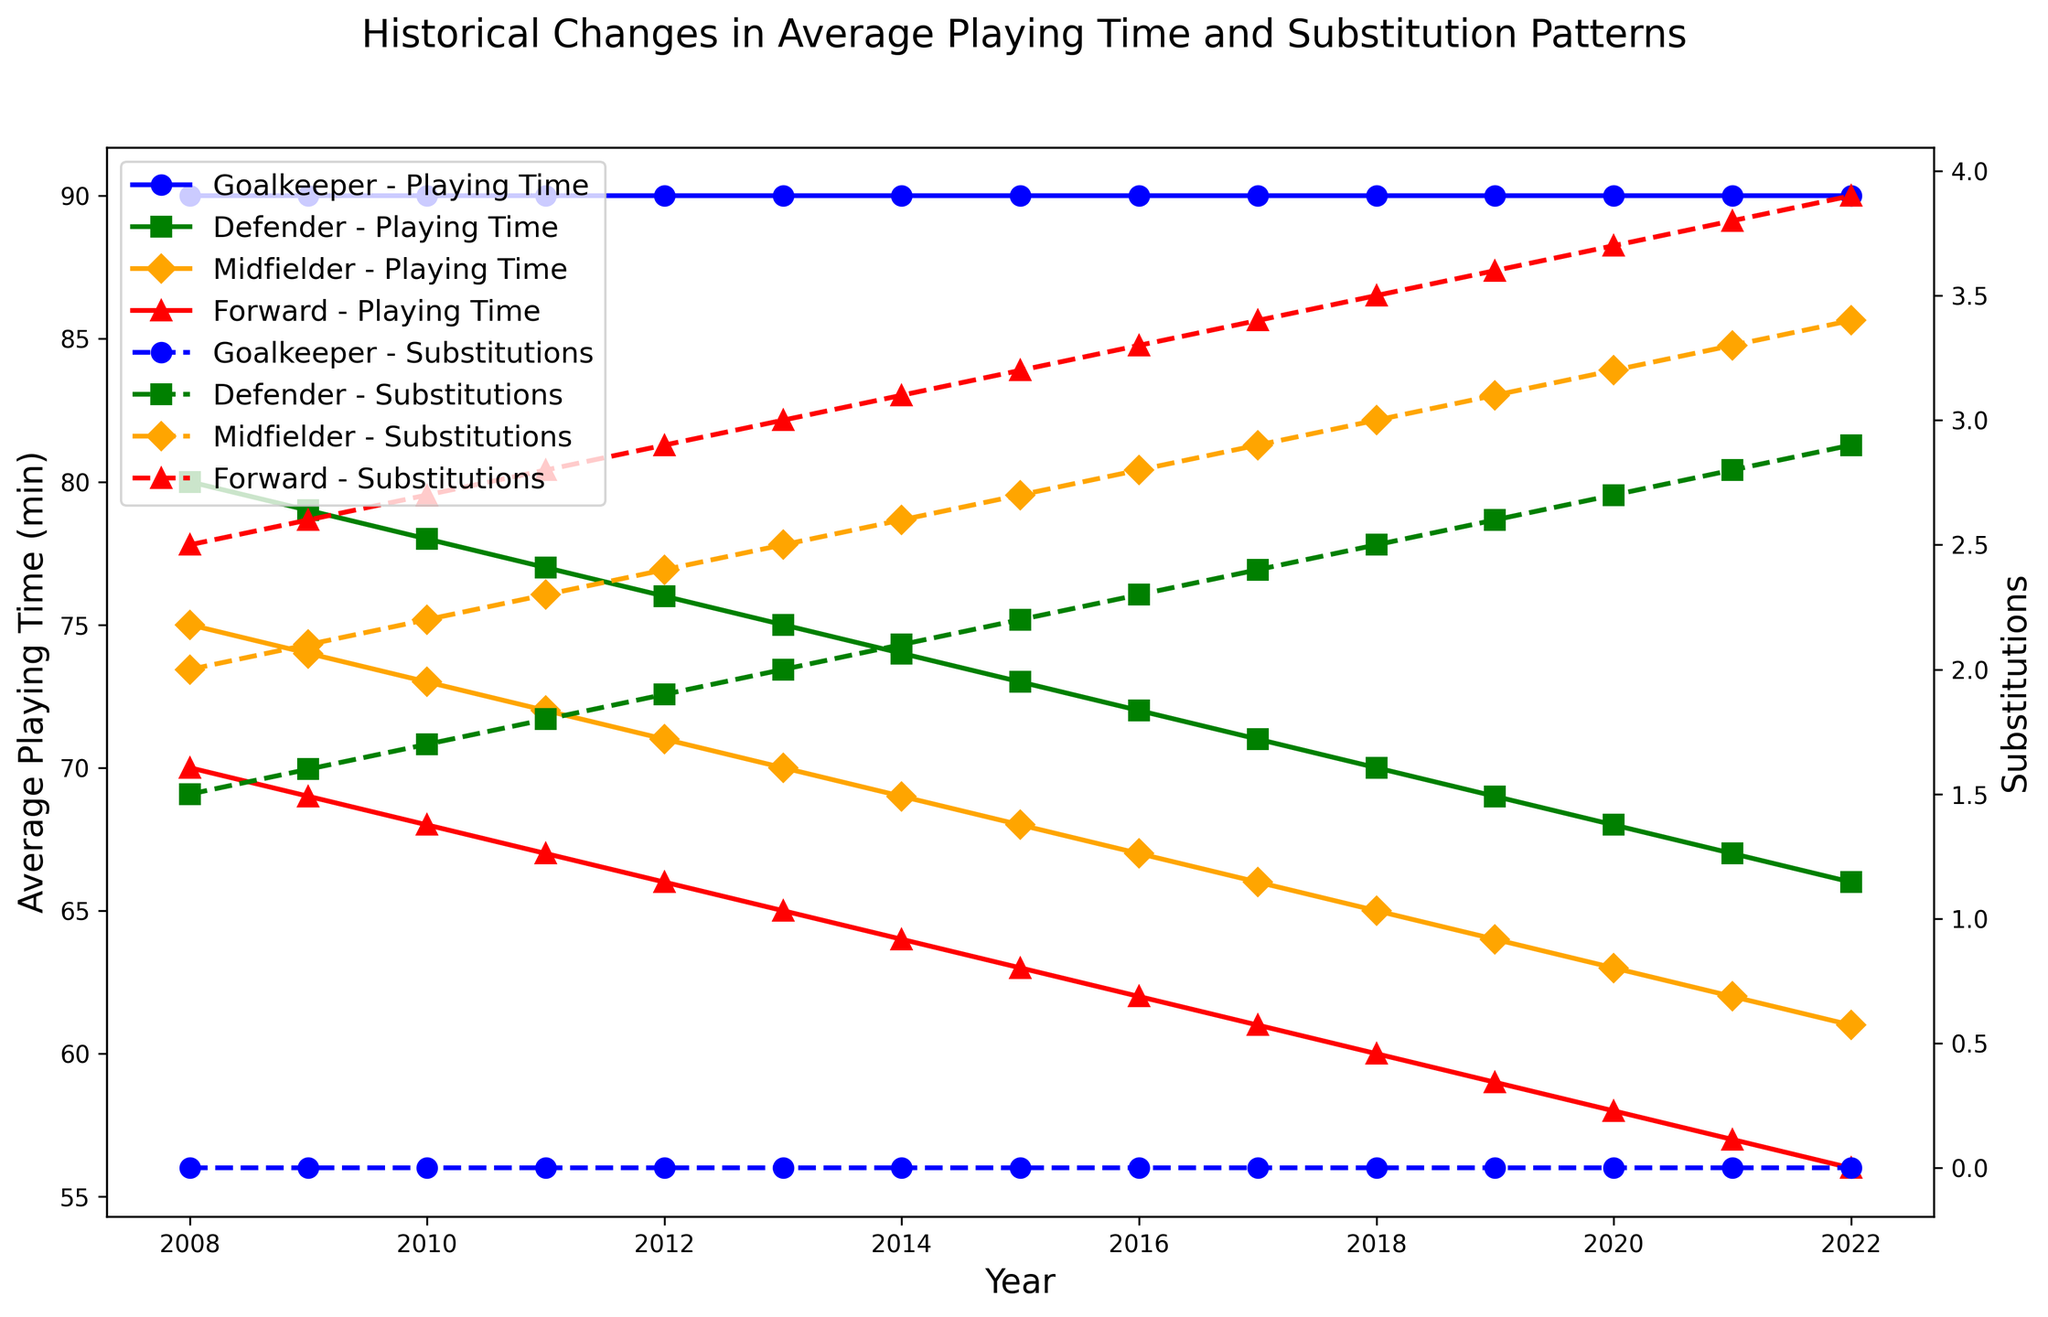What is the average playing time of Goalkeepers over the years? The average playing time for Goalkeepers is consistently shown at 90 minutes each year.
Answer: 90 minutes How do the substitution patterns of Forwards in 2022 compare to those in 2008? In 2008, Forwards had an average of 2.5 substitutions, while in 2022, this increased to 3.9 substitutions. The difference is 3.9 - 2.5 = 1.4.
Answer: 1.4 Which position saw the greatest decrease in average playing time from 2008 to 2022? Goalkeepers maintained a constant playing time of 90 minutes. Forwards had the largest decrease from 70 minutes in 2008 to 56 minutes in 2022, which is a change of 70 - 56 = 14 minutes.
Answer: Forwards In which year did Midfielders have the highest average playing time, and what was it? By examining the data trends, Midfielders had the highest average playing time in 2008 with 75 minutes.
Answer: 2008, 75 minutes Are Defenders substituted more frequently than Midfielders in 2020? For 2020, Defenders had 2.7 substitutions, while Midfielders had 3.2 substitutions. Midfielders were substituted more frequently.
Answer: No What is the trend in average playing time for Defenders over the years? Defenders' playing time decreased progressively from 80 minutes in 2008 to 66 minutes in 2022.
Answer: Decreasing How does the substitution pattern for Midfielders in 2015 compare to 2022? In 2015, Midfielders had 2.7 substitutions, which increased to 3.4 substitutions in 2022. The difference is 3.4 - 2.7 = 0.7.
Answer: 0.7 Are the substitution patterns for Goalkeepers different from other positions? Yes. Goalkeepers did not have any substitutions (always 0), unlike other positions that had increasing substitution counts over the years.
Answer: Yes Which position has the steepest trend in decreasing average playing time? By analyzing the lines, Forwards have the steepest decrease in average playing time (from 70 minutes in 2008 to 56 minutes in 2022).
Answer: Forwards In which year did Defenders first have an average playing time below 70 minutes? By checking the trends, Defenders first had an average playing time below 70 minutes in the year 2018.
Answer: 2018 